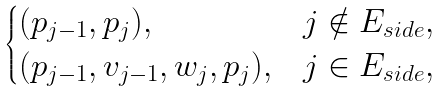<formula> <loc_0><loc_0><loc_500><loc_500>\begin{cases} ( p _ { j - 1 } , p _ { j } ) , & j \notin E _ { s i d e } , \\ ( p _ { j - 1 } , v _ { j - 1 } , w _ { j } , p _ { j } ) , & j \in E _ { s i d e } , \end{cases}</formula> 